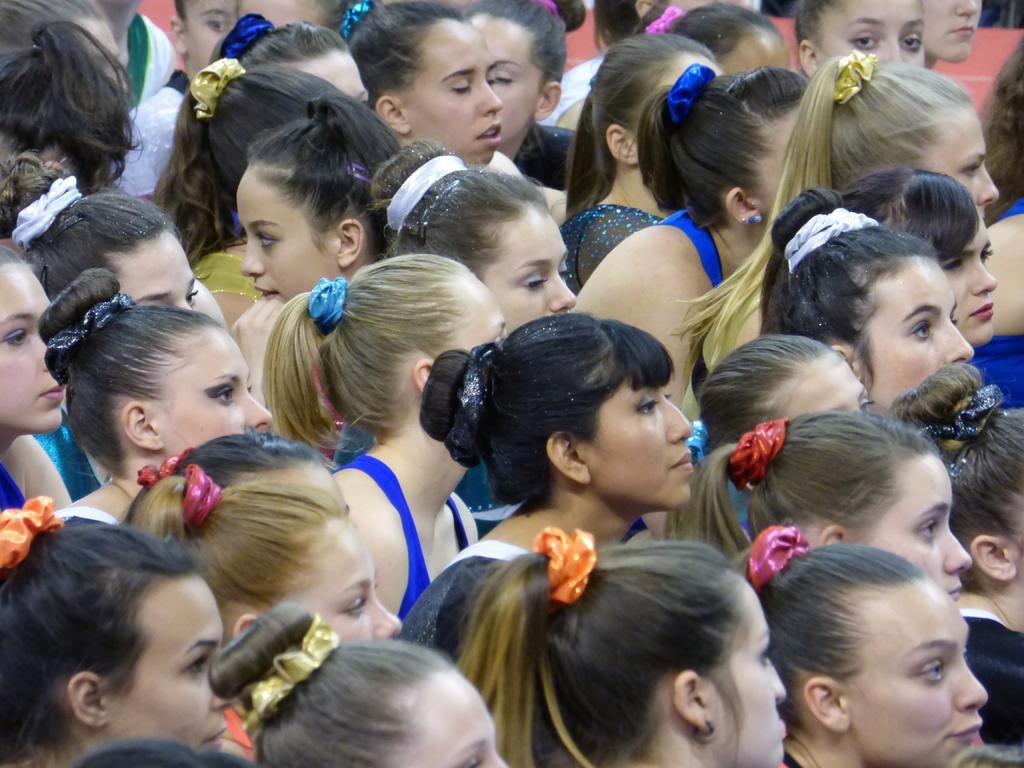How many people are in the image? There is a group of people in the image. What are some of the people in the group doing? Some of the people in the group are talking. What type of story is being told by the people in the image? There is no indication in the image that a story is being told, as the provided facts only mention that some people are talking. 